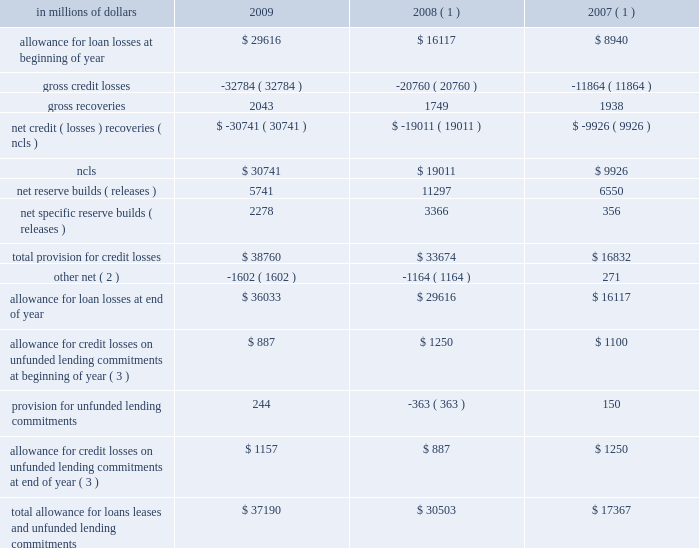18 .
Allowance for credit losses .
( 1 ) reclassified to conform to the current period 2019s presentation .
( 2 ) 2009 primarily includes reductions to the loan loss reserve of approximately $ 543 million related to securitizations , approximately $ 402 million related to the sale or transfers to held-for-sale of u.s .
Real estate lending loans , and $ 562 million related to the transfer of the u.k .
Cards portfolio to held-for-sale .
2008 primarily includes reductions to the loan loss reserve of approximately $ 800 million related to fx translation , $ 102 million related to securitizations , $ 244 million for the sale of the german retail banking operation , $ 156 million for the sale of citicapital , partially offset by additions of $ 106 million related to the cuscatl e1n and bank of overseas chinese acquisitions .
2007 primarily includes reductions to the loan loss reserve of $ 475 million related to securitizations and transfers to loans held-for-sale , and reductions of $ 83 million related to the transfer of the u.k .
Citifinancial portfolio to held-for-sale , offset by additions of $ 610 million related to the acquisitions of egg , nikko cordial , grupo cuscatl e1n and grupo financiero uno .
( 3 ) represents additional credit loss reserves for unfunded corporate lending commitments and letters of credit recorded in other liabilities on the consolidated balance sheet. .
What was the percentage change in the allowance for loan losses from 2008 to 2009? 
Computations: ((29616 - 16117) / 16117)
Answer: 0.83756. 